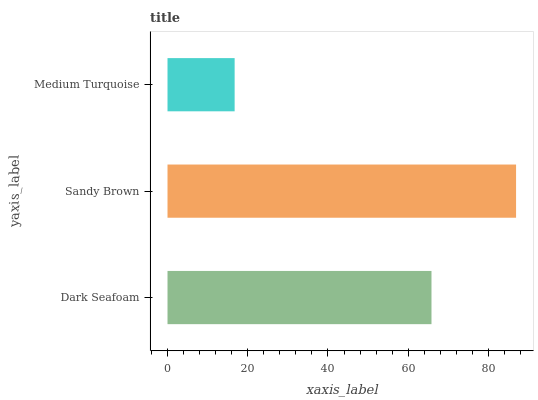Is Medium Turquoise the minimum?
Answer yes or no. Yes. Is Sandy Brown the maximum?
Answer yes or no. Yes. Is Sandy Brown the minimum?
Answer yes or no. No. Is Medium Turquoise the maximum?
Answer yes or no. No. Is Sandy Brown greater than Medium Turquoise?
Answer yes or no. Yes. Is Medium Turquoise less than Sandy Brown?
Answer yes or no. Yes. Is Medium Turquoise greater than Sandy Brown?
Answer yes or no. No. Is Sandy Brown less than Medium Turquoise?
Answer yes or no. No. Is Dark Seafoam the high median?
Answer yes or no. Yes. Is Dark Seafoam the low median?
Answer yes or no. Yes. Is Medium Turquoise the high median?
Answer yes or no. No. Is Sandy Brown the low median?
Answer yes or no. No. 